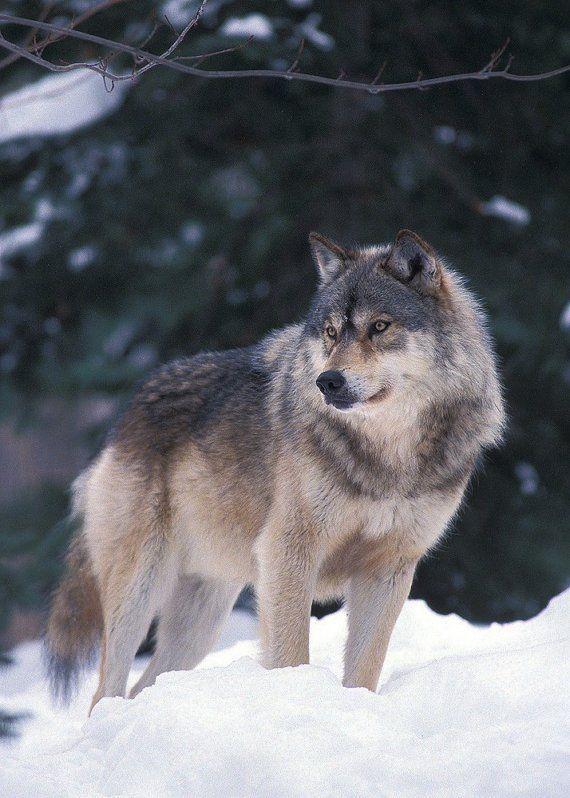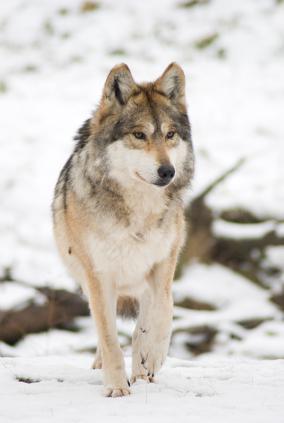The first image is the image on the left, the second image is the image on the right. Examine the images to the left and right. Is the description "There is a wolf lying down with its head raised." accurate? Answer yes or no. No. The first image is the image on the left, the second image is the image on the right. Assess this claim about the two images: "The dog in the image on the left is on snow.". Correct or not? Answer yes or no. No. 